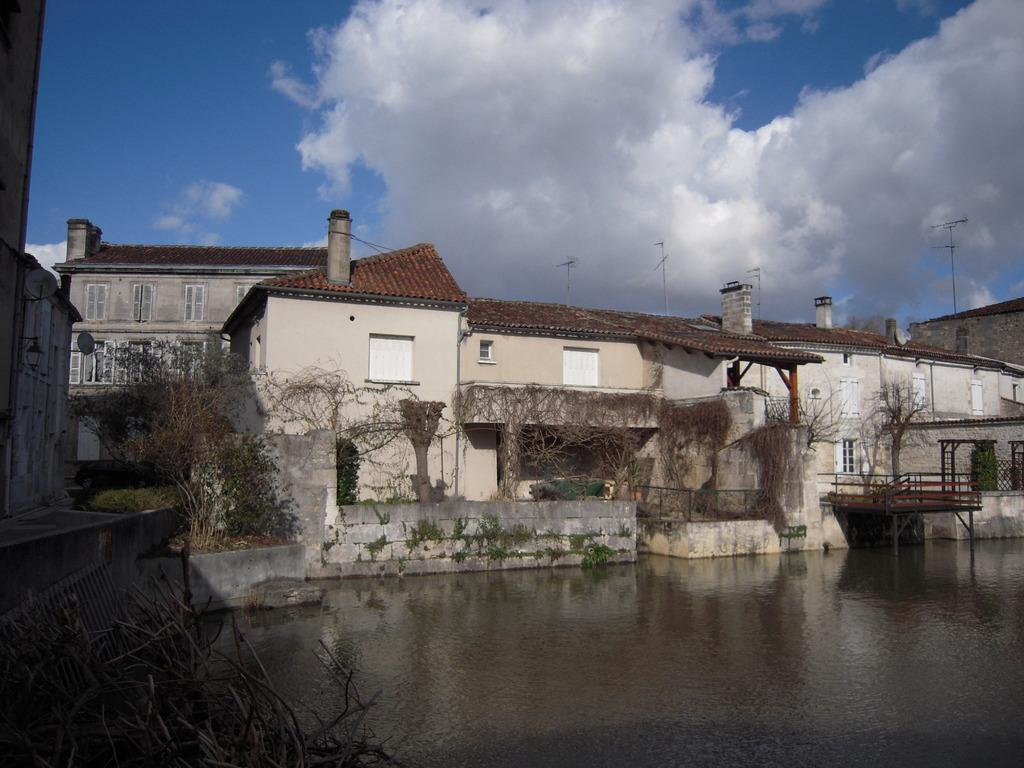What is the primary element visible in the image? There is water in the image. What type of vegetation can be seen in the image? There are trees in the image. What type of structures are present in the image? There are buildings with windows in the image. What type of platform is visible in the image? There is a deck with poles in the image. What is located on the left side of the image? There is a grille on the left side of the image. What can be seen in the background of the image? The sky with clouds is visible in the background of the image. How many cobwebs can be seen in the image? There are no cobwebs present in the image. How many friends are visible in the image? There are no people, including friends, present in the image. 